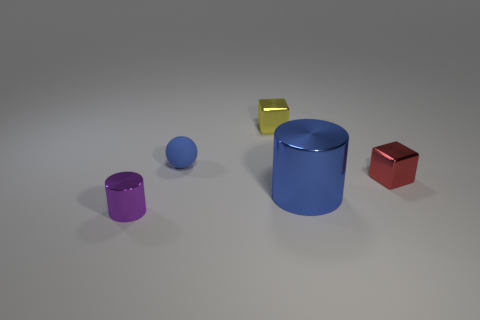Is there any other thing that has the same size as the blue shiny object?
Offer a terse response. No. There is a metal thing behind the small red shiny cube; are there any small blue rubber objects that are behind it?
Provide a short and direct response. No. There is a tiny shiny cube that is in front of the yellow metallic block; how many blue cylinders are left of it?
Provide a succinct answer. 1. There is a blue ball that is the same size as the purple shiny cylinder; what is it made of?
Ensure brevity in your answer.  Rubber. There is a thing behind the small blue matte sphere; does it have the same shape as the red metal thing?
Offer a very short reply. Yes. Is the number of metal things behind the red metallic object greater than the number of tiny red metal objects left of the blue matte sphere?
Your answer should be compact. Yes. How many red objects have the same material as the yellow thing?
Ensure brevity in your answer.  1. Is the red block the same size as the blue shiny object?
Make the answer very short. No. The big object has what color?
Give a very brief answer. Blue. How many objects are either metal cylinders or small blue cubes?
Ensure brevity in your answer.  2. 